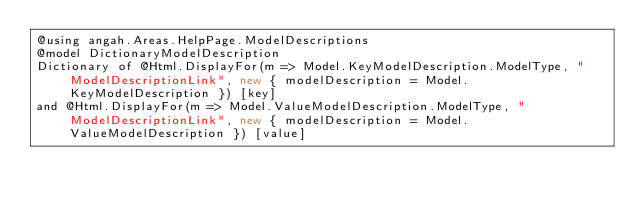Convert code to text. <code><loc_0><loc_0><loc_500><loc_500><_C#_>@using angah.Areas.HelpPage.ModelDescriptions
@model DictionaryModelDescription
Dictionary of @Html.DisplayFor(m => Model.KeyModelDescription.ModelType, "ModelDescriptionLink", new { modelDescription = Model.KeyModelDescription }) [key]
and @Html.DisplayFor(m => Model.ValueModelDescription.ModelType, "ModelDescriptionLink", new { modelDescription = Model.ValueModelDescription }) [value]</code> 